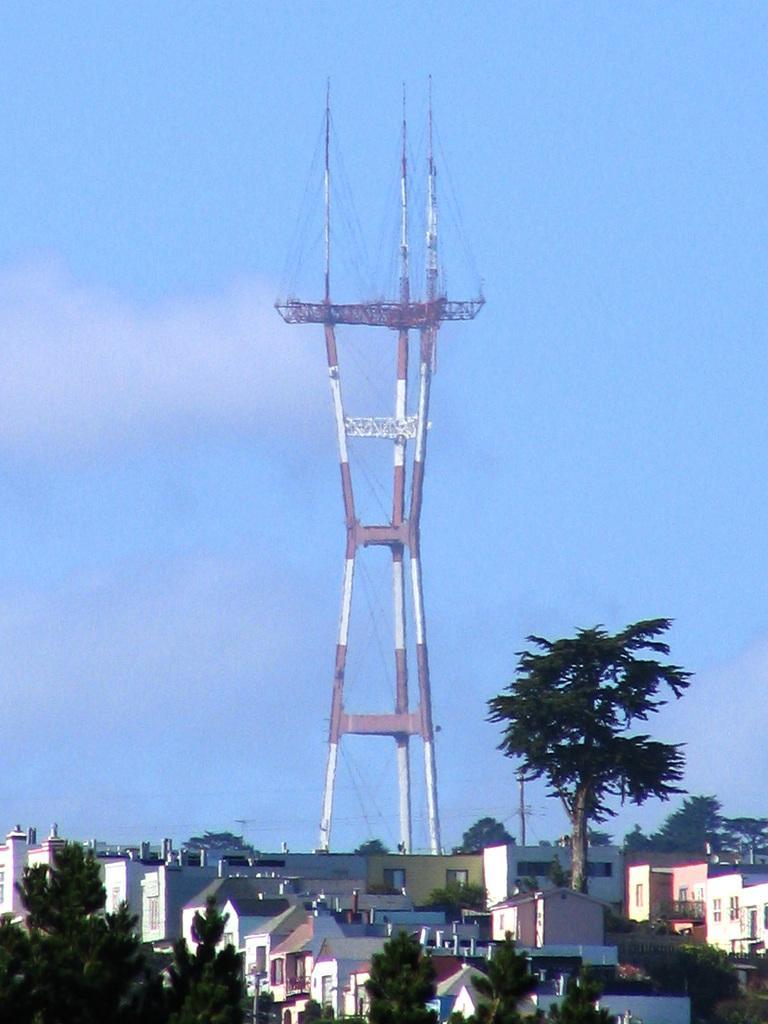How would you summarize this image in a sentence or two? This is the picture of a city. In this image there are buildings and trees and there is a tower and there are wires on the tower. At the top there is sky and there are clouds. 